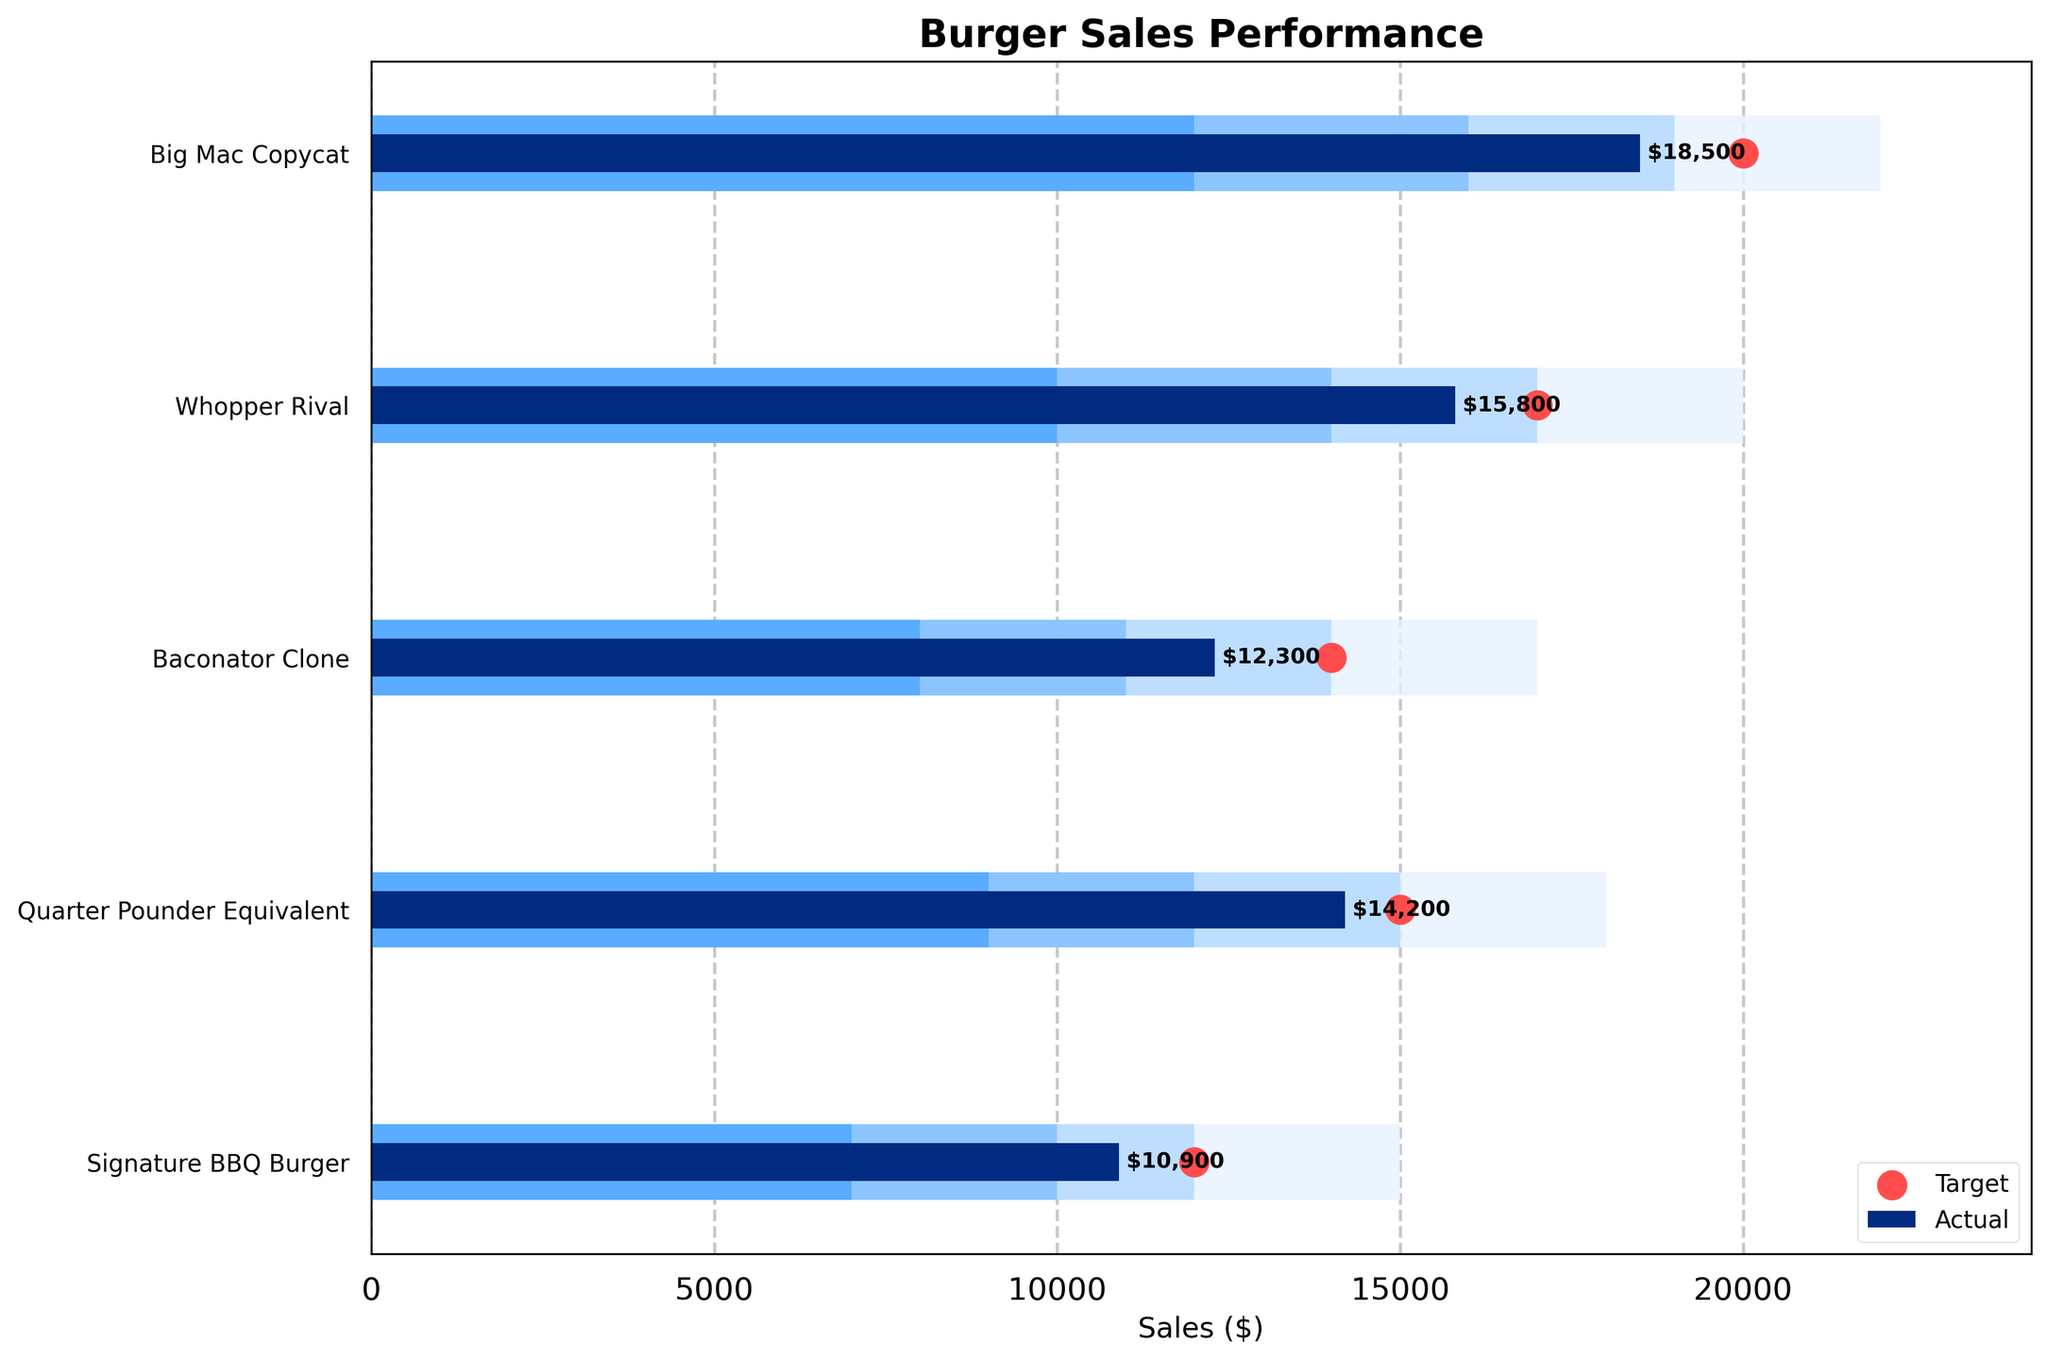what is the highest sales target among the burgers? The sales target values are plotted as red dots on the horizontal axis. The highest target value can be identified by visually scanning the red dots and comparing their positions. The "Big Mac Copycat" has the highest target with a value of $20,000.
Answer: $20,000 Which burger's actual sales are closest to its target? We need to find the burger where the blue bar (actual sales) is closest in length to the position of the corresponding red dot (target). The "Whopper Rival" has actual sales of $15,800 and a target of $17,000, making the difference $1,200, which is the smallest among all burgers.
Answer: Whopper Rival What's the total sales for "Signature BBQ Burger" and "Quarter Pounder Equivalent"? The actual sales for "Signature BBQ Burger" is $10,900 and for "Quarter Pounder Equivalent" is $14,200. Adding these two values gives us $10,900 + $14,200 = $25,100.
Answer: $25,100 How many burgers have actual sales above 15,000? By examining the length of the blue bars, we see that "Big Mac Copycat" (18,500) and "Whopper Rival" (15,800) have actual sales above 15,000. There are 2 burgers that meet the criteria.
Answer: 2 Which burger performed poorest in terms of actual sales? Examining the lengths of the blue bars, we see that the "Signature BBQ Burger" has the shortest bar, indicating the lowest actual sales of $10,900.
Answer: Signature BBQ Burger What's the difference between the highest and lowest sales targets? From the figure, we can see that the highest target is for "Big Mac Copycat" at $20,000 and the lowest is "Signature BBQ Burger" at $12,000. The difference is $20,000 - $12,000 = $8,000.
Answer: $8,000 Which burger has the largest gap between actual sales and its satisfactory threshold? We compare the actual values for each burger to their satisfactory values. "Quarter Pounder Equivalent" has actual sales of $14,200, which is above its satisfactory threshold of $12,000 by $2,200. It's the largest gap.
Answer: Quarter Pounder Equivalent In which performance category does "Baconator Clone" fall based on its actual sales? The "Baconator Clone" actual sales are $12,300. We identify the color bars to determine categories: Poor (<$11,000), Satisfactory ($11,000 - $14,000), Good ($14,000 - $17,000), and VeryGood (>$17,000). $12,300 falls within the satisfactory range.
Answer: Satisfactory 